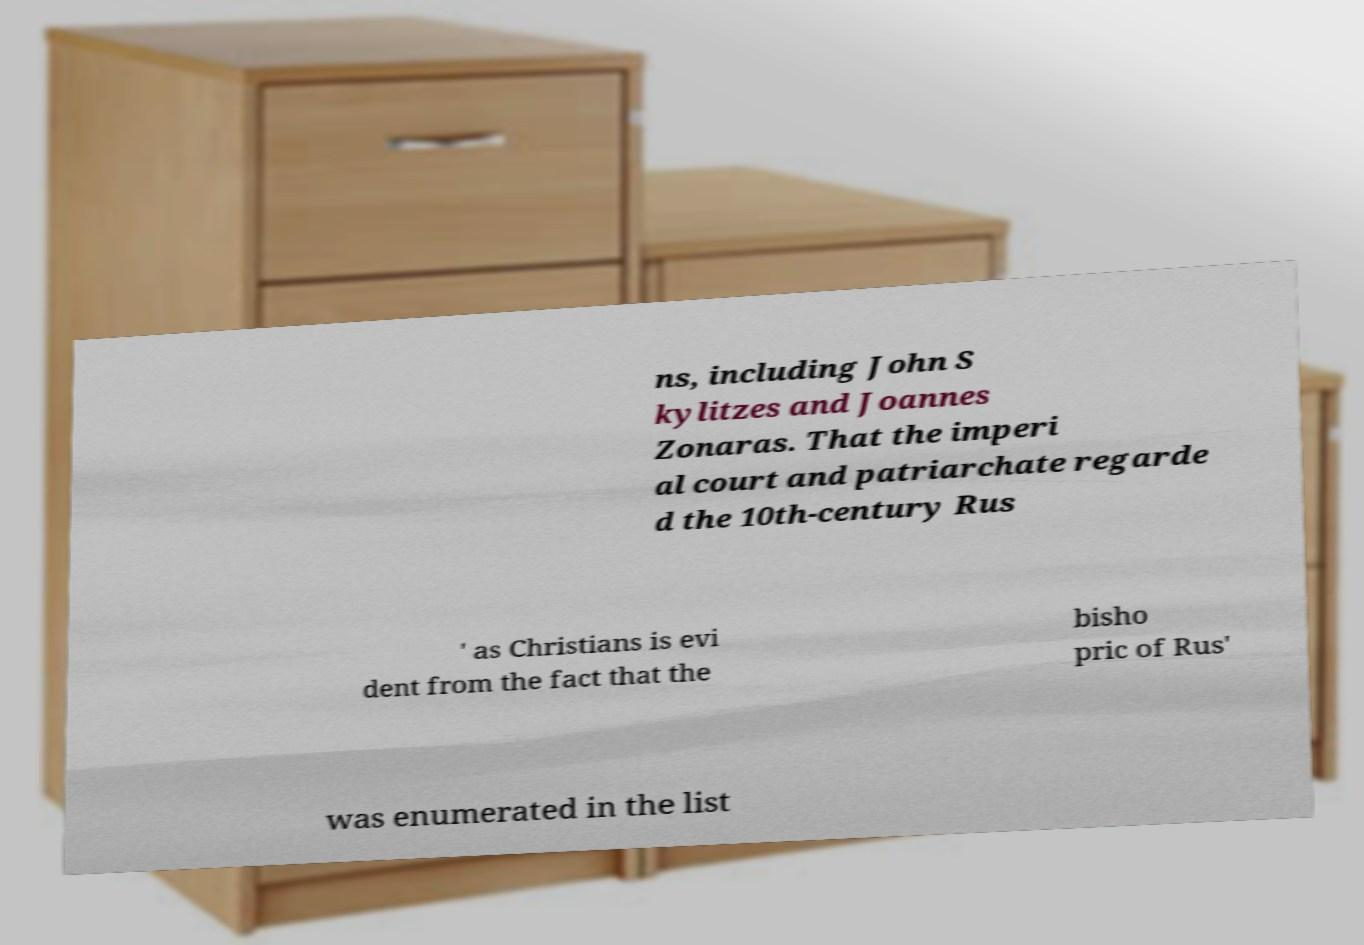Could you assist in decoding the text presented in this image and type it out clearly? ns, including John S kylitzes and Joannes Zonaras. That the imperi al court and patriarchate regarde d the 10th-century Rus ' as Christians is evi dent from the fact that the bisho pric of Rus' was enumerated in the list 